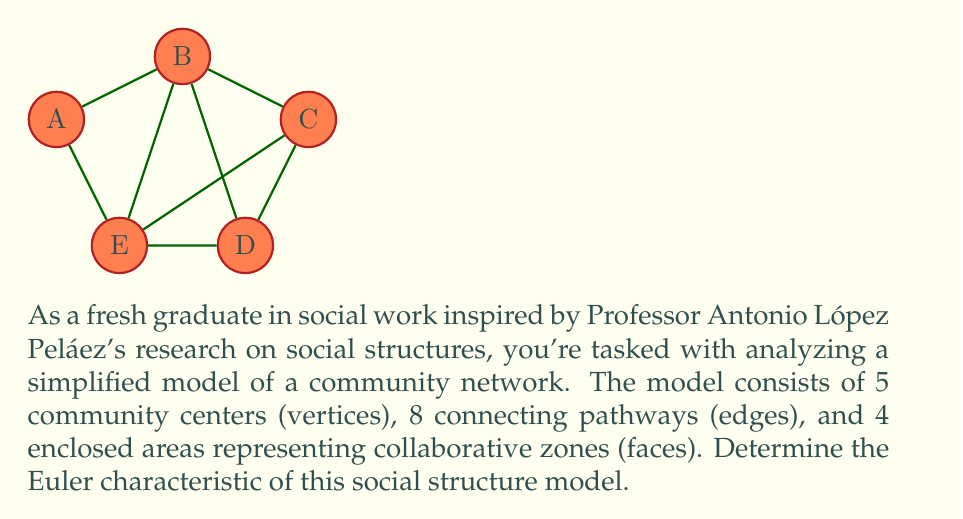Can you solve this math problem? To determine the Euler characteristic of this simplified social structure model, we'll follow these steps:

1) Recall the Euler characteristic formula:
   $$\chi = V - E + F$$
   where $\chi$ is the Euler characteristic, $V$ is the number of vertices, $E$ is the number of edges, and $F$ is the number of faces.

2) Count the components of our model:
   - Vertices (V): 5 community centers
   - Edges (E): 8 connecting pathways
   - Faces (F): 4 enclosed collaborative zones + 1 exterior face = 5 total faces

3) Substitute these values into the Euler characteristic formula:
   $$\chi = V - E + F$$
   $$\chi = 5 - 8 + 5$$

4) Calculate:
   $$\chi = 2$$

The Euler characteristic of 2 indicates that this social structure model is topologically equivalent to a sphere, which is a common result for planar graphs. This characteristic doesn't change under continuous deformations, suggesting a fundamental property of the network's connectivity that persists regardless of the specific layout of community centers and pathways.
Answer: $\chi = 2$ 